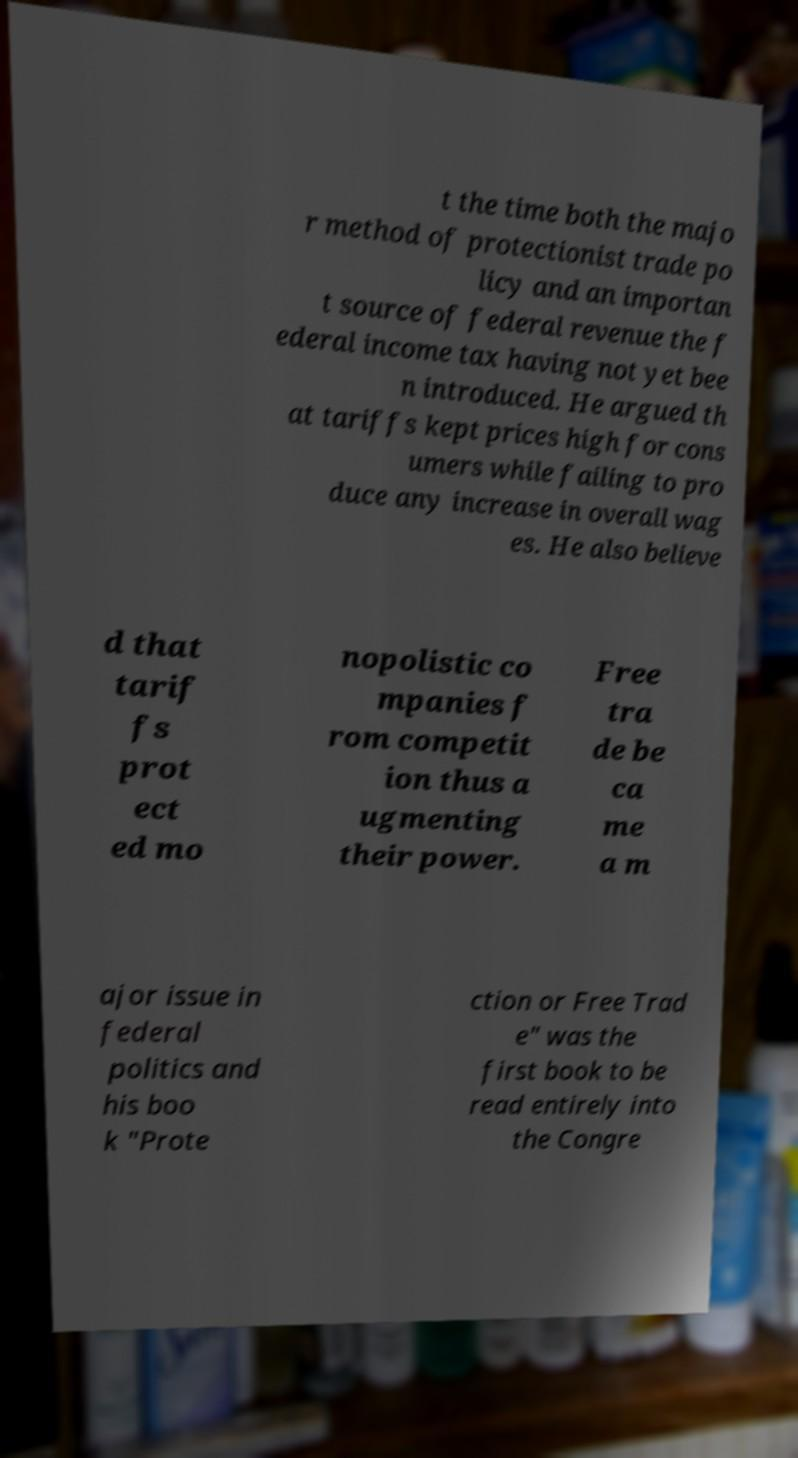Can you accurately transcribe the text from the provided image for me? t the time both the majo r method of protectionist trade po licy and an importan t source of federal revenue the f ederal income tax having not yet bee n introduced. He argued th at tariffs kept prices high for cons umers while failing to pro duce any increase in overall wag es. He also believe d that tarif fs prot ect ed mo nopolistic co mpanies f rom competit ion thus a ugmenting their power. Free tra de be ca me a m ajor issue in federal politics and his boo k "Prote ction or Free Trad e" was the first book to be read entirely into the Congre 